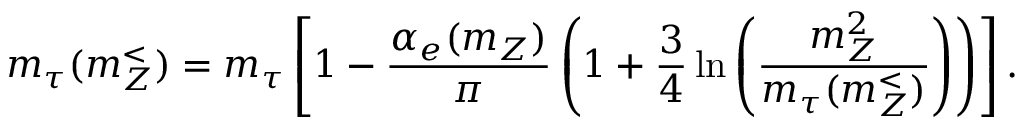Convert formula to latex. <formula><loc_0><loc_0><loc_500><loc_500>m _ { \tau } ( m _ { Z } ^ { < } ) = m _ { \tau } \left [ 1 - \frac { \alpha _ { e } ( m _ { Z } ) } { \pi } \left ( 1 + \frac { 3 } { 4 } \ln \left ( \frac { m _ { Z } ^ { 2 } } { m _ { \tau } ( m _ { Z } ^ { < } ) } \right ) \right ) \right ] .</formula> 